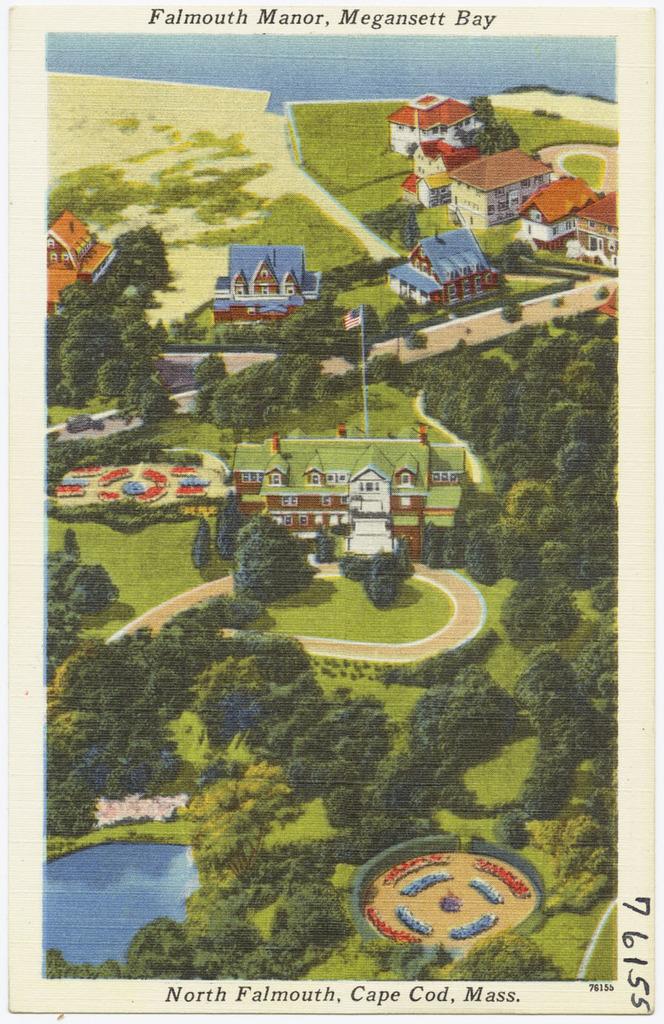Where is this postcard picture taken?
Provide a succinct answer. Falmouth manor, megansett bay. What is the card numbered?
Keep it short and to the point. 76155. 